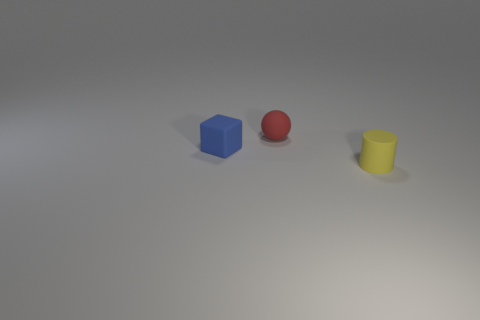Do the red matte sphere and the blue cube have the same size?
Your response must be concise. Yes. How many other things are the same size as the rubber block?
Make the answer very short. 2. How many things are either small matte things in front of the red ball or objects behind the blue object?
Offer a terse response. 3. There is a yellow rubber thing that is the same size as the red ball; what shape is it?
Provide a succinct answer. Cylinder. The red object that is made of the same material as the cylinder is what size?
Your answer should be compact. Small. Does the tiny blue thing have the same shape as the yellow rubber object?
Keep it short and to the point. No. What color is the matte sphere that is the same size as the matte cylinder?
Ensure brevity in your answer.  Red. What is the shape of the small rubber object that is on the left side of the small red object?
Your answer should be very brief. Cube. Does the tiny red rubber thing have the same shape as the object that is in front of the matte block?
Offer a very short reply. No. Is the number of small cylinders that are behind the yellow cylinder the same as the number of tiny things in front of the red object?
Your answer should be compact. No. 